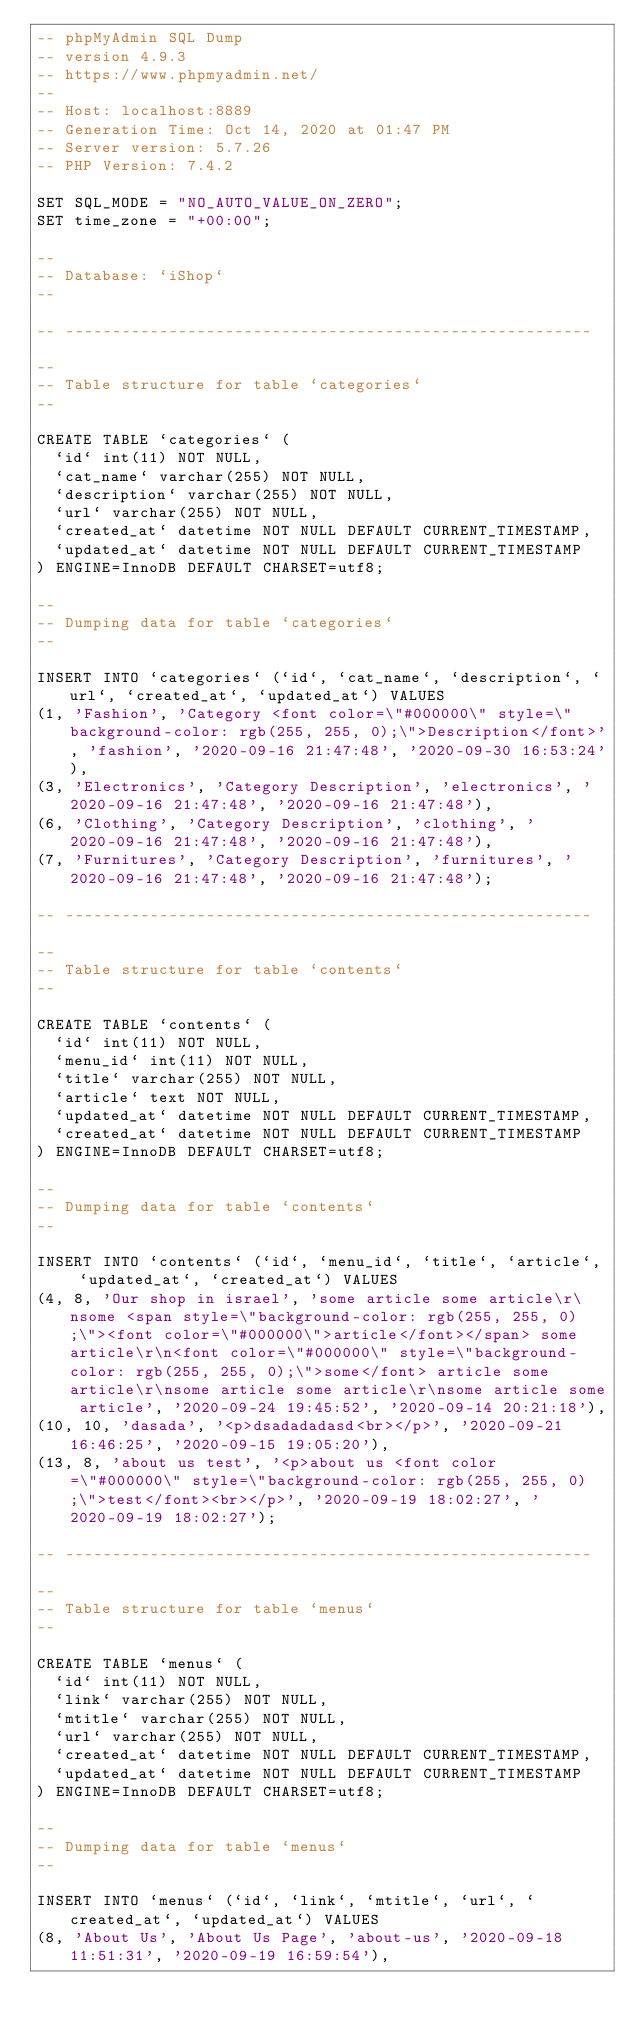Convert code to text. <code><loc_0><loc_0><loc_500><loc_500><_SQL_>-- phpMyAdmin SQL Dump
-- version 4.9.3
-- https://www.phpmyadmin.net/
--
-- Host: localhost:8889
-- Generation Time: Oct 14, 2020 at 01:47 PM
-- Server version: 5.7.26
-- PHP Version: 7.4.2

SET SQL_MODE = "NO_AUTO_VALUE_ON_ZERO";
SET time_zone = "+00:00";

--
-- Database: `iShop`
--

-- --------------------------------------------------------

--
-- Table structure for table `categories`
--

CREATE TABLE `categories` (
  `id` int(11) NOT NULL,
  `cat_name` varchar(255) NOT NULL,
  `description` varchar(255) NOT NULL,
  `url` varchar(255) NOT NULL,
  `created_at` datetime NOT NULL DEFAULT CURRENT_TIMESTAMP,
  `updated_at` datetime NOT NULL DEFAULT CURRENT_TIMESTAMP
) ENGINE=InnoDB DEFAULT CHARSET=utf8;

--
-- Dumping data for table `categories`
--

INSERT INTO `categories` (`id`, `cat_name`, `description`, `url`, `created_at`, `updated_at`) VALUES
(1, 'Fashion', 'Category <font color=\"#000000\" style=\"background-color: rgb(255, 255, 0);\">Description</font>', 'fashion', '2020-09-16 21:47:48', '2020-09-30 16:53:24'),
(3, 'Electronics', 'Category Description', 'electronics', '2020-09-16 21:47:48', '2020-09-16 21:47:48'),
(6, 'Clothing', 'Category Description', 'clothing', '2020-09-16 21:47:48', '2020-09-16 21:47:48'),
(7, 'Furnitures', 'Category Description', 'furnitures', '2020-09-16 21:47:48', '2020-09-16 21:47:48');

-- --------------------------------------------------------

--
-- Table structure for table `contents`
--

CREATE TABLE `contents` (
  `id` int(11) NOT NULL,
  `menu_id` int(11) NOT NULL,
  `title` varchar(255) NOT NULL,
  `article` text NOT NULL,
  `updated_at` datetime NOT NULL DEFAULT CURRENT_TIMESTAMP,
  `created_at` datetime NOT NULL DEFAULT CURRENT_TIMESTAMP
) ENGINE=InnoDB DEFAULT CHARSET=utf8;

--
-- Dumping data for table `contents`
--

INSERT INTO `contents` (`id`, `menu_id`, `title`, `article`, `updated_at`, `created_at`) VALUES
(4, 8, 'Our shop in israel', 'some article some article\r\nsome <span style=\"background-color: rgb(255, 255, 0);\"><font color=\"#000000\">article</font></span> some article\r\n<font color=\"#000000\" style=\"background-color: rgb(255, 255, 0);\">some</font> article some article\r\nsome article some article\r\nsome article some article', '2020-09-24 19:45:52', '2020-09-14 20:21:18'),
(10, 10, 'dasada', '<p>dsadadadasd<br></p>', '2020-09-21 16:46:25', '2020-09-15 19:05:20'),
(13, 8, 'about us test', '<p>about us <font color=\"#000000\" style=\"background-color: rgb(255, 255, 0);\">test</font><br></p>', '2020-09-19 18:02:27', '2020-09-19 18:02:27');

-- --------------------------------------------------------

--
-- Table structure for table `menus`
--

CREATE TABLE `menus` (
  `id` int(11) NOT NULL,
  `link` varchar(255) NOT NULL,
  `mtitle` varchar(255) NOT NULL,
  `url` varchar(255) NOT NULL,
  `created_at` datetime NOT NULL DEFAULT CURRENT_TIMESTAMP,
  `updated_at` datetime NOT NULL DEFAULT CURRENT_TIMESTAMP
) ENGINE=InnoDB DEFAULT CHARSET=utf8;

--
-- Dumping data for table `menus`
--

INSERT INTO `menus` (`id`, `link`, `mtitle`, `url`, `created_at`, `updated_at`) VALUES
(8, 'About Us', 'About Us Page', 'about-us', '2020-09-18 11:51:31', '2020-09-19 16:59:54'),</code> 